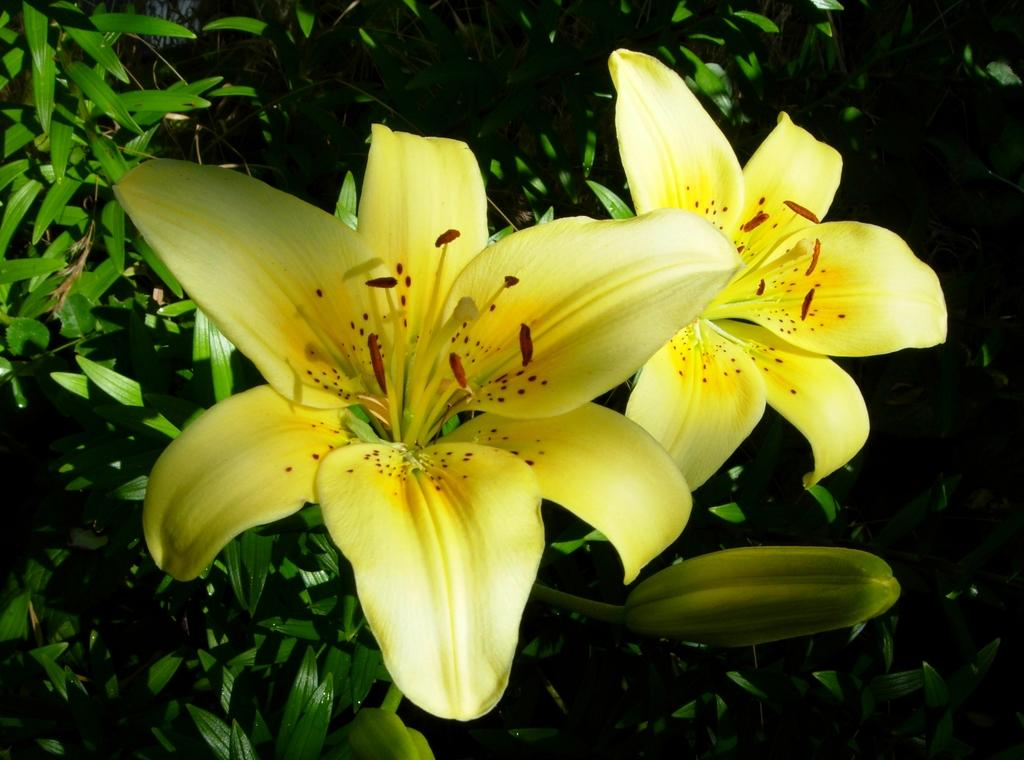What is located in the middle of the image? There are two flowers in the middle of the image. What else can be seen in the image besides the flowers? There are plants visible behind the flowers. Where is the key hidden in the image? There is no key present in the image; it only features two flowers and plants. 